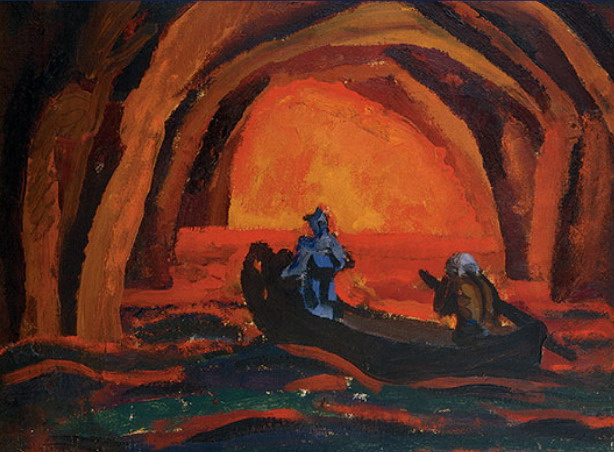What do you see happening in this image? The painting captures an intimate and evocative scene, set within a vast cave illuminated by an ambience of warm glows ranging from bright orange to deepest red. A boat gently navigates the still waters, carrying two figures clad in blue that create a stark contrast against the fiery backdrop. The style of the painting is impressionistic, focusing heavily on the emotion conveyed through vibrant colors and bold brushstrokes, which invite the viewer to experience the tranquility and mystery of this subterranean journey. 